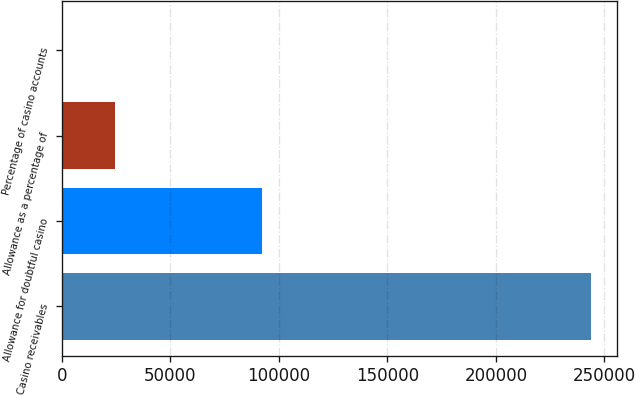Convert chart to OTSL. <chart><loc_0><loc_0><loc_500><loc_500><bar_chart><fcel>Casino receivables<fcel>Allowance for doubtful casino<fcel>Allowance as a percentage of<fcel>Percentage of casino accounts<nl><fcel>243600<fcel>92278<fcel>24378.9<fcel>21<nl></chart> 